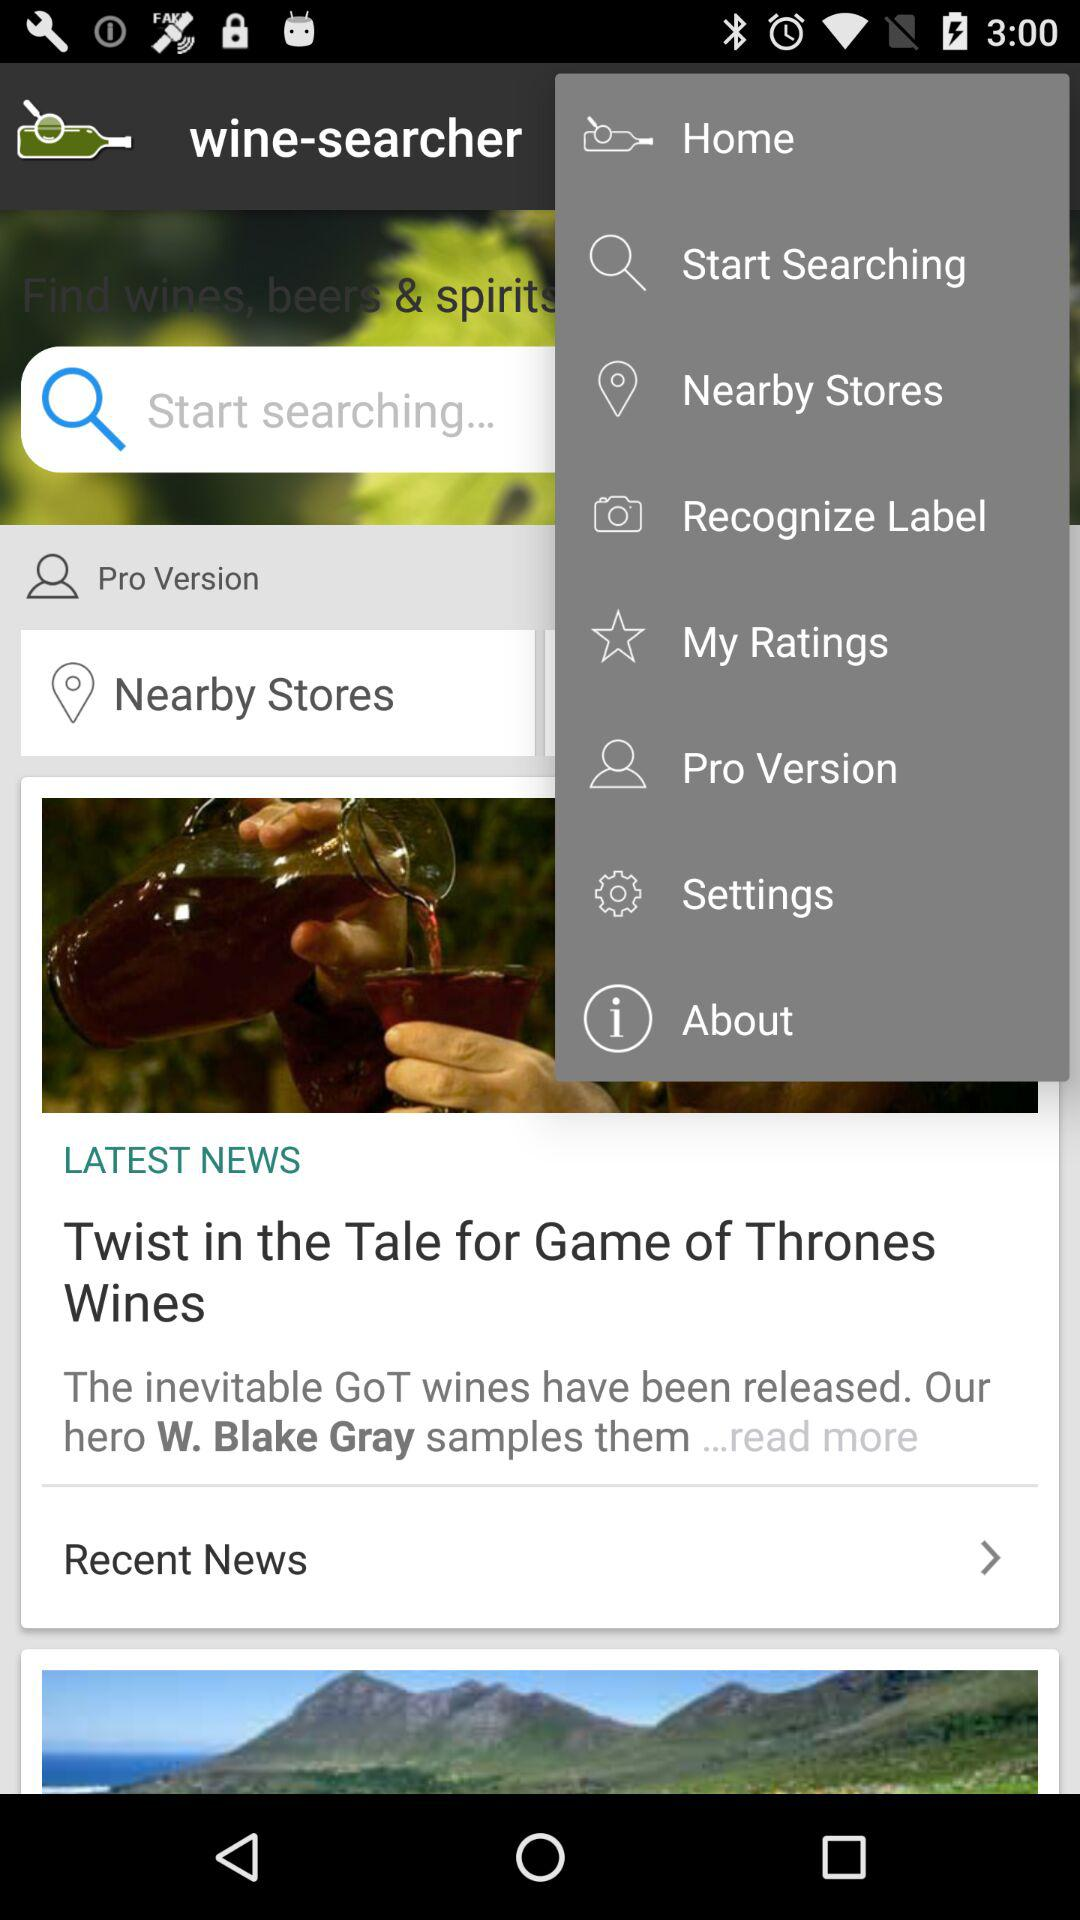Which option is selected in the drop-down menu?
When the provided information is insufficient, respond with <no answer>. <no answer> 